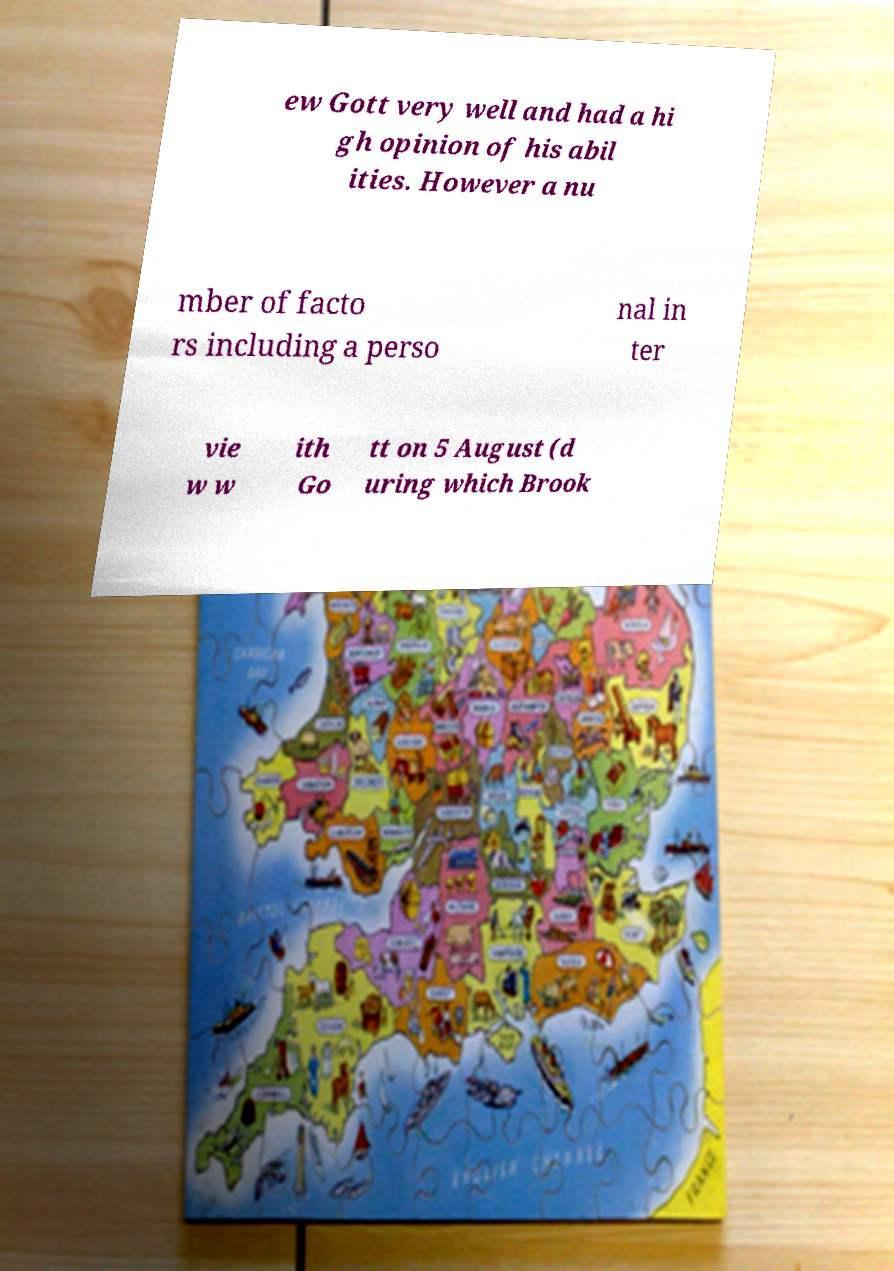Please identify and transcribe the text found in this image. ew Gott very well and had a hi gh opinion of his abil ities. However a nu mber of facto rs including a perso nal in ter vie w w ith Go tt on 5 August (d uring which Brook 